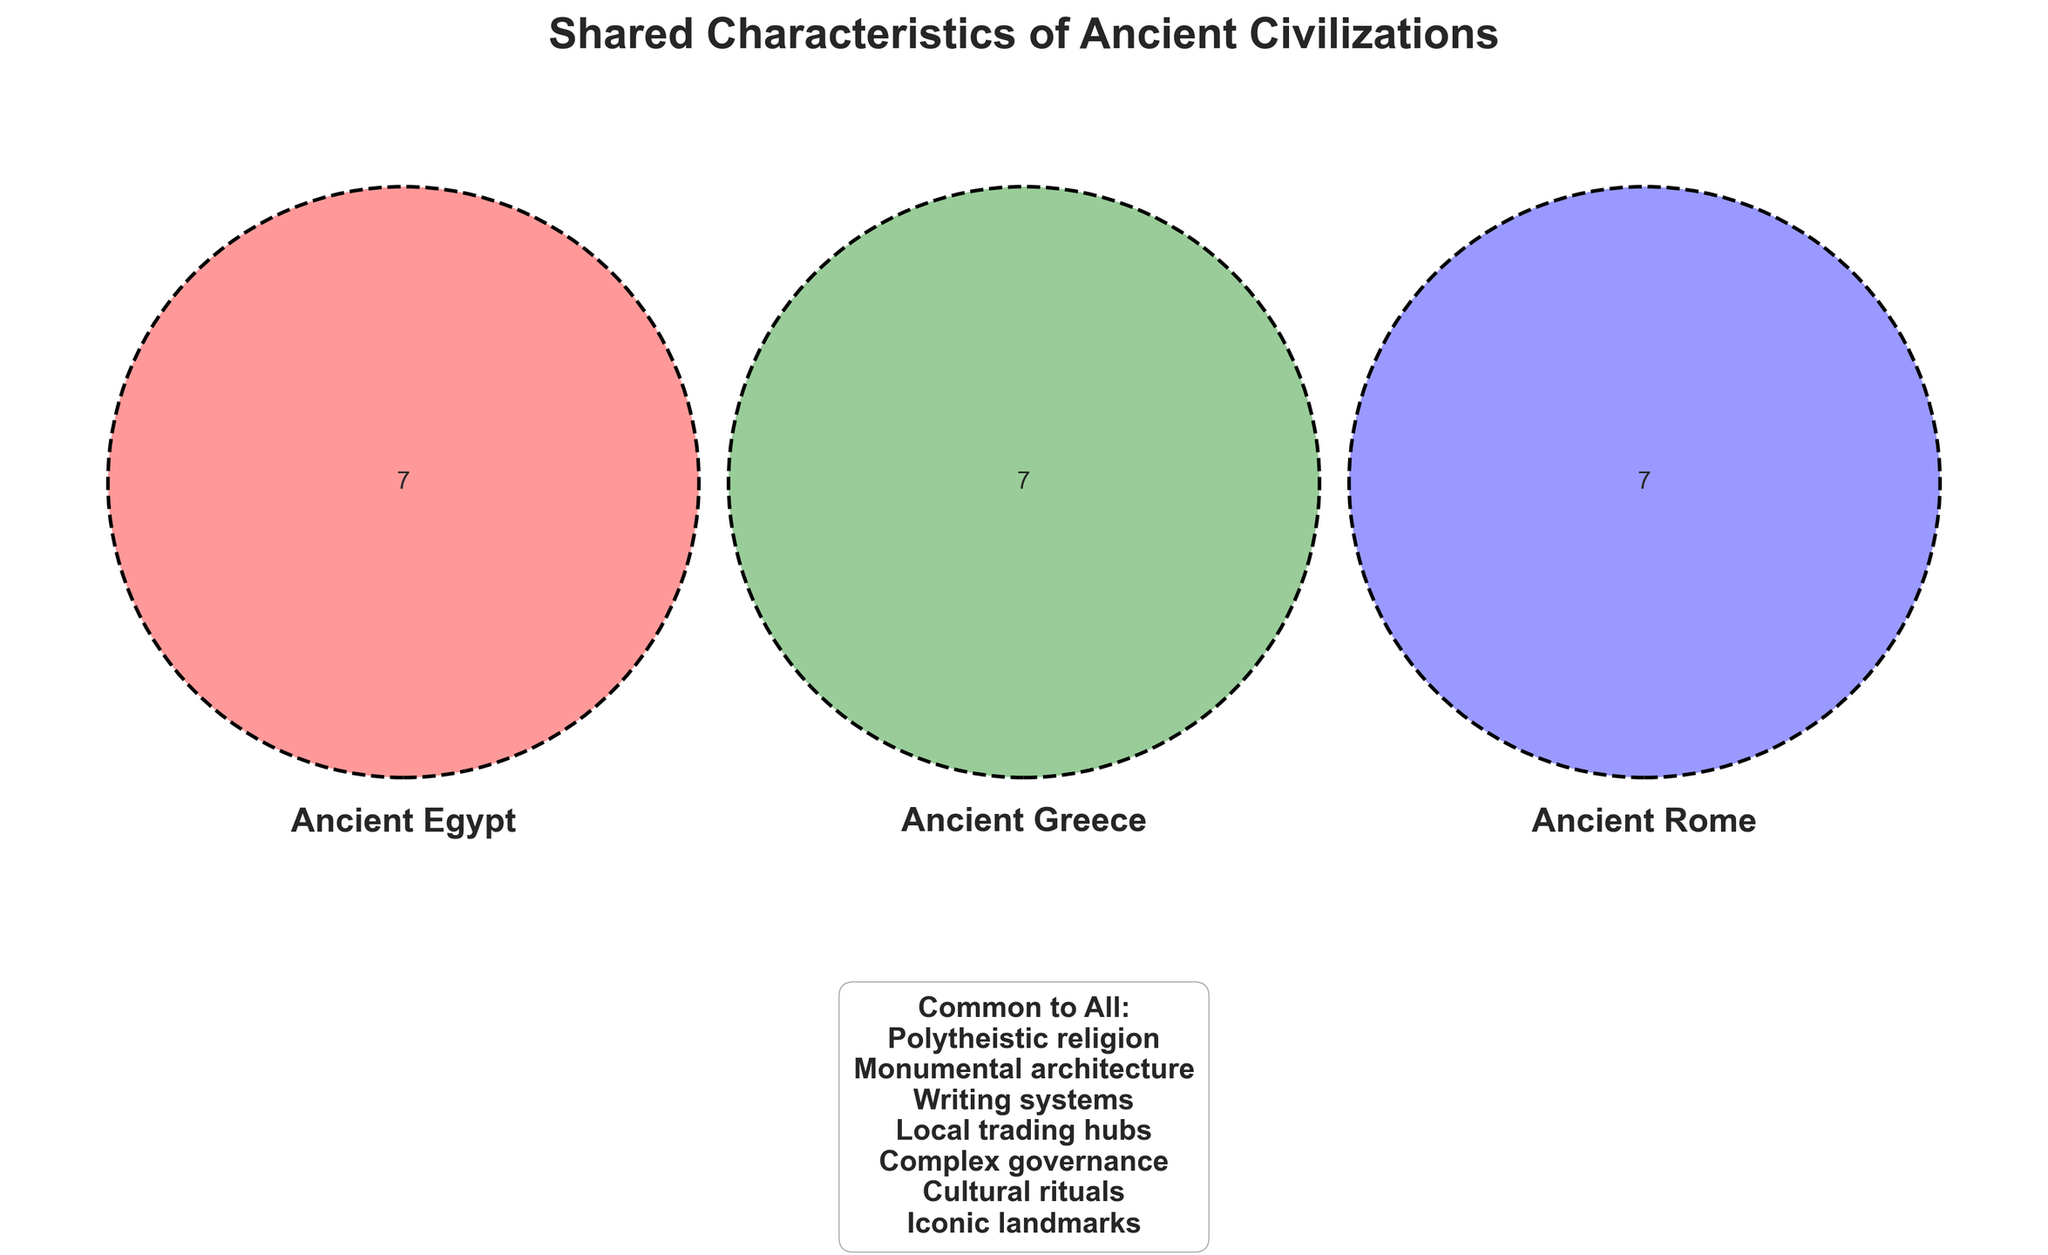What are the shared characteristics of all three Ancient Egypt, Ancient Greece, and Ancient Rome? The Venn diagram includes text in the center that lists the common characteristics shared by all three civilizations. This text in the center states the shared traits.
Answer: Polytheistic religion, Monumental architecture, Writing systems, Local trading hubs, Complex governance, Cultural rituals, Iconic landmarks Which civilization is associated with Pyramids? The Venn diagram shows the characteristic "Pyramids" exclusively in the section corresponding to Ancient Egypt. By finding this, we can identify the association.
Answer: Ancient Egypt Name a cultural ritual unique to Ancient Greece displayed in the diagram. The Venn diagram places different cultural rituals in exclusive sections. The "Olympics" is positioned in the sector uniquely representing Ancient Greece.
Answer: Olympics Compare the governance systems of the civilizations. Which one had a Republic? The Venn diagram labels characteristics related to governance in respective sections. The term "Republic" is placed in the section corresponding to Ancient Rome.
Answer: Ancient Rome Identify the characteristic related to monumental architecture for Ancient Rome. Each civilization's monumental architecture is mentioned in separate sections. The "Colosseum" is found in the section for Ancient Rome.
Answer: Colosseum Which civilization had a market known as the Agora? The Venn diagram includes markets in different sections. The "Agora markets" are shown in the section for Ancient Greece.
Answer: Ancient Greece What writing system is specific to Ancient Egypt? The Venn diagram's sections for writing systems are unique to each civilization. "Hieroglyphics" appears in the area for Ancient Egypt.
Answer: Hieroglyphics Mention an iconic landmark unique to Ancient Egypt. Iconic landmarks are positioned separately in the diagram. The "Sphinx" is unique to Ancient Egypt and placed in its corresponding section.
Answer: Sphinx What are the unique characteristics of Ancient Rome shown in the diagram? The diagram labels unique characteristics specific to each civilization in their own sections. For Ancient Rome, they are: Colosseum, Latin, Forum markets, Republic, Gladiator games, Pantheon.
Answer: Colosseum, Latin, Forum markets, Republic, Gladiator games, Pantheon 